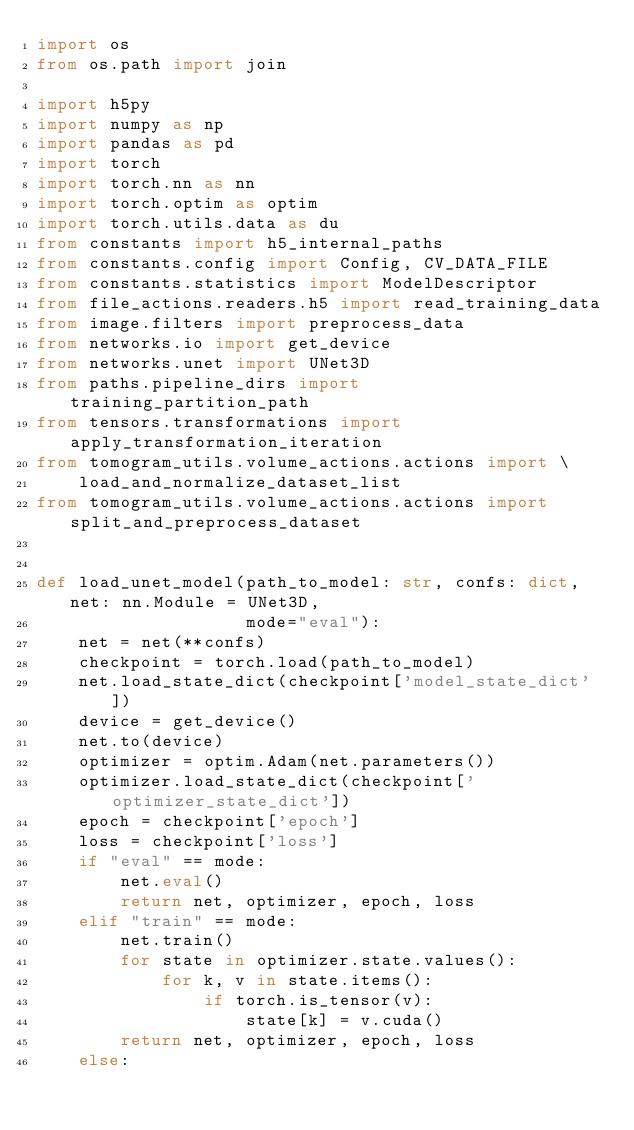<code> <loc_0><loc_0><loc_500><loc_500><_Python_>import os
from os.path import join

import h5py
import numpy as np
import pandas as pd
import torch
import torch.nn as nn
import torch.optim as optim
import torch.utils.data as du
from constants import h5_internal_paths
from constants.config import Config, CV_DATA_FILE
from constants.statistics import ModelDescriptor
from file_actions.readers.h5 import read_training_data
from image.filters import preprocess_data
from networks.io import get_device
from networks.unet import UNet3D
from paths.pipeline_dirs import training_partition_path
from tensors.transformations import apply_transformation_iteration
from tomogram_utils.volume_actions.actions import \
    load_and_normalize_dataset_list
from tomogram_utils.volume_actions.actions import split_and_preprocess_dataset


def load_unet_model(path_to_model: str, confs: dict, net: nn.Module = UNet3D,
                    mode="eval"):
    net = net(**confs)
    checkpoint = torch.load(path_to_model)
    net.load_state_dict(checkpoint['model_state_dict'])
    device = get_device()
    net.to(device)
    optimizer = optim.Adam(net.parameters())
    optimizer.load_state_dict(checkpoint['optimizer_state_dict'])
    epoch = checkpoint['epoch']
    loss = checkpoint['loss']
    if "eval" == mode:
        net.eval()
        return net, optimizer, epoch, loss
    elif "train" == mode:
        net.train()
        for state in optimizer.state.values():
            for k, v in state.items():
                if torch.is_tensor(v):
                    state[k] = v.cuda()
        return net, optimizer, epoch, loss
    else:</code> 